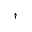<formula> <loc_0><loc_0><loc_500><loc_500>^ { \dagger }</formula> 